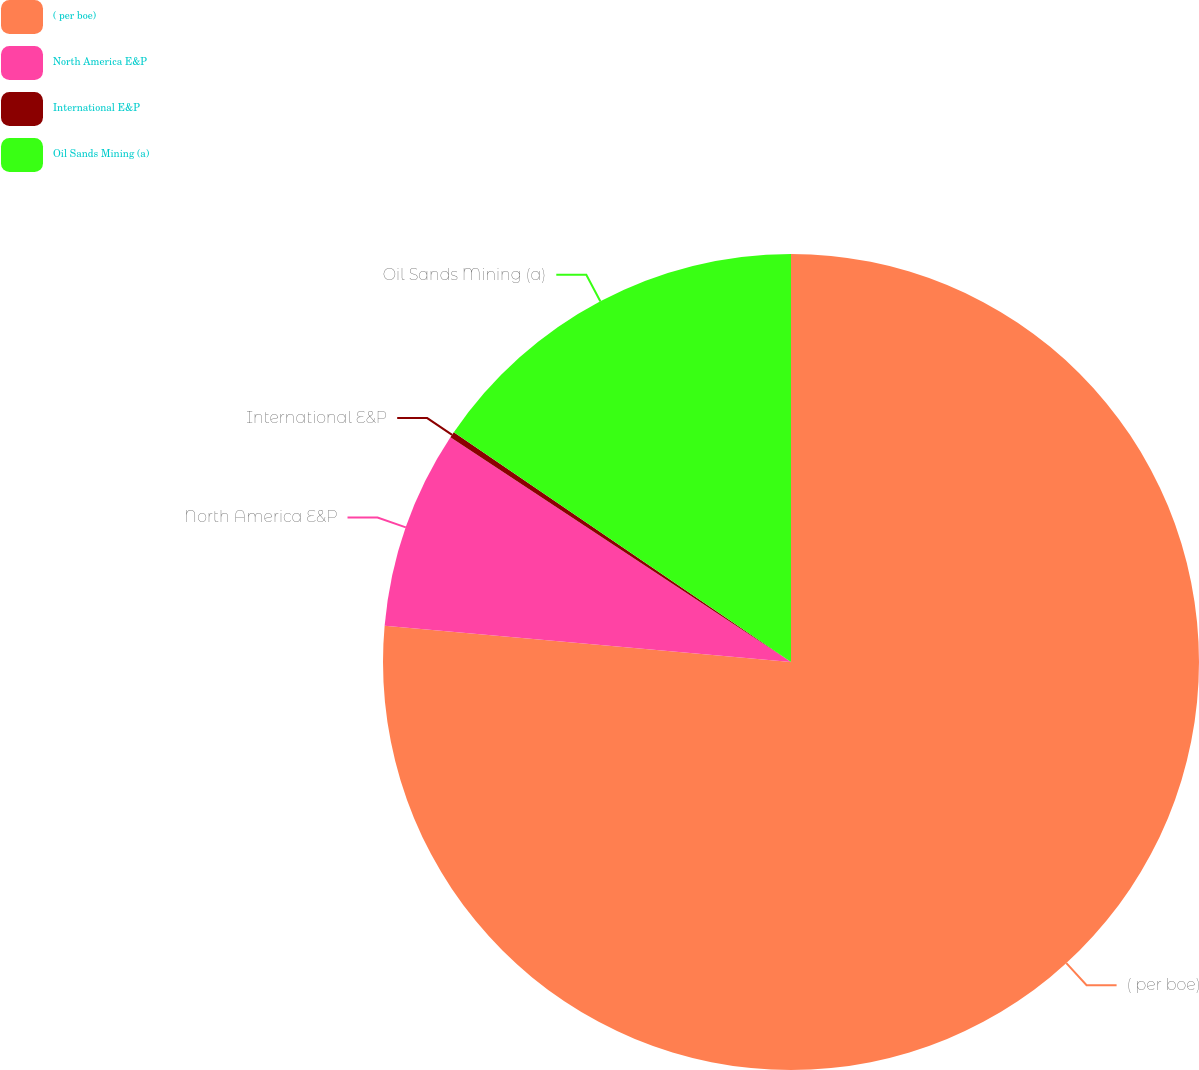<chart> <loc_0><loc_0><loc_500><loc_500><pie_chart><fcel>( per boe)<fcel>North America E&P<fcel>International E&P<fcel>Oil Sands Mining (a)<nl><fcel>76.42%<fcel>7.86%<fcel>0.24%<fcel>15.48%<nl></chart> 